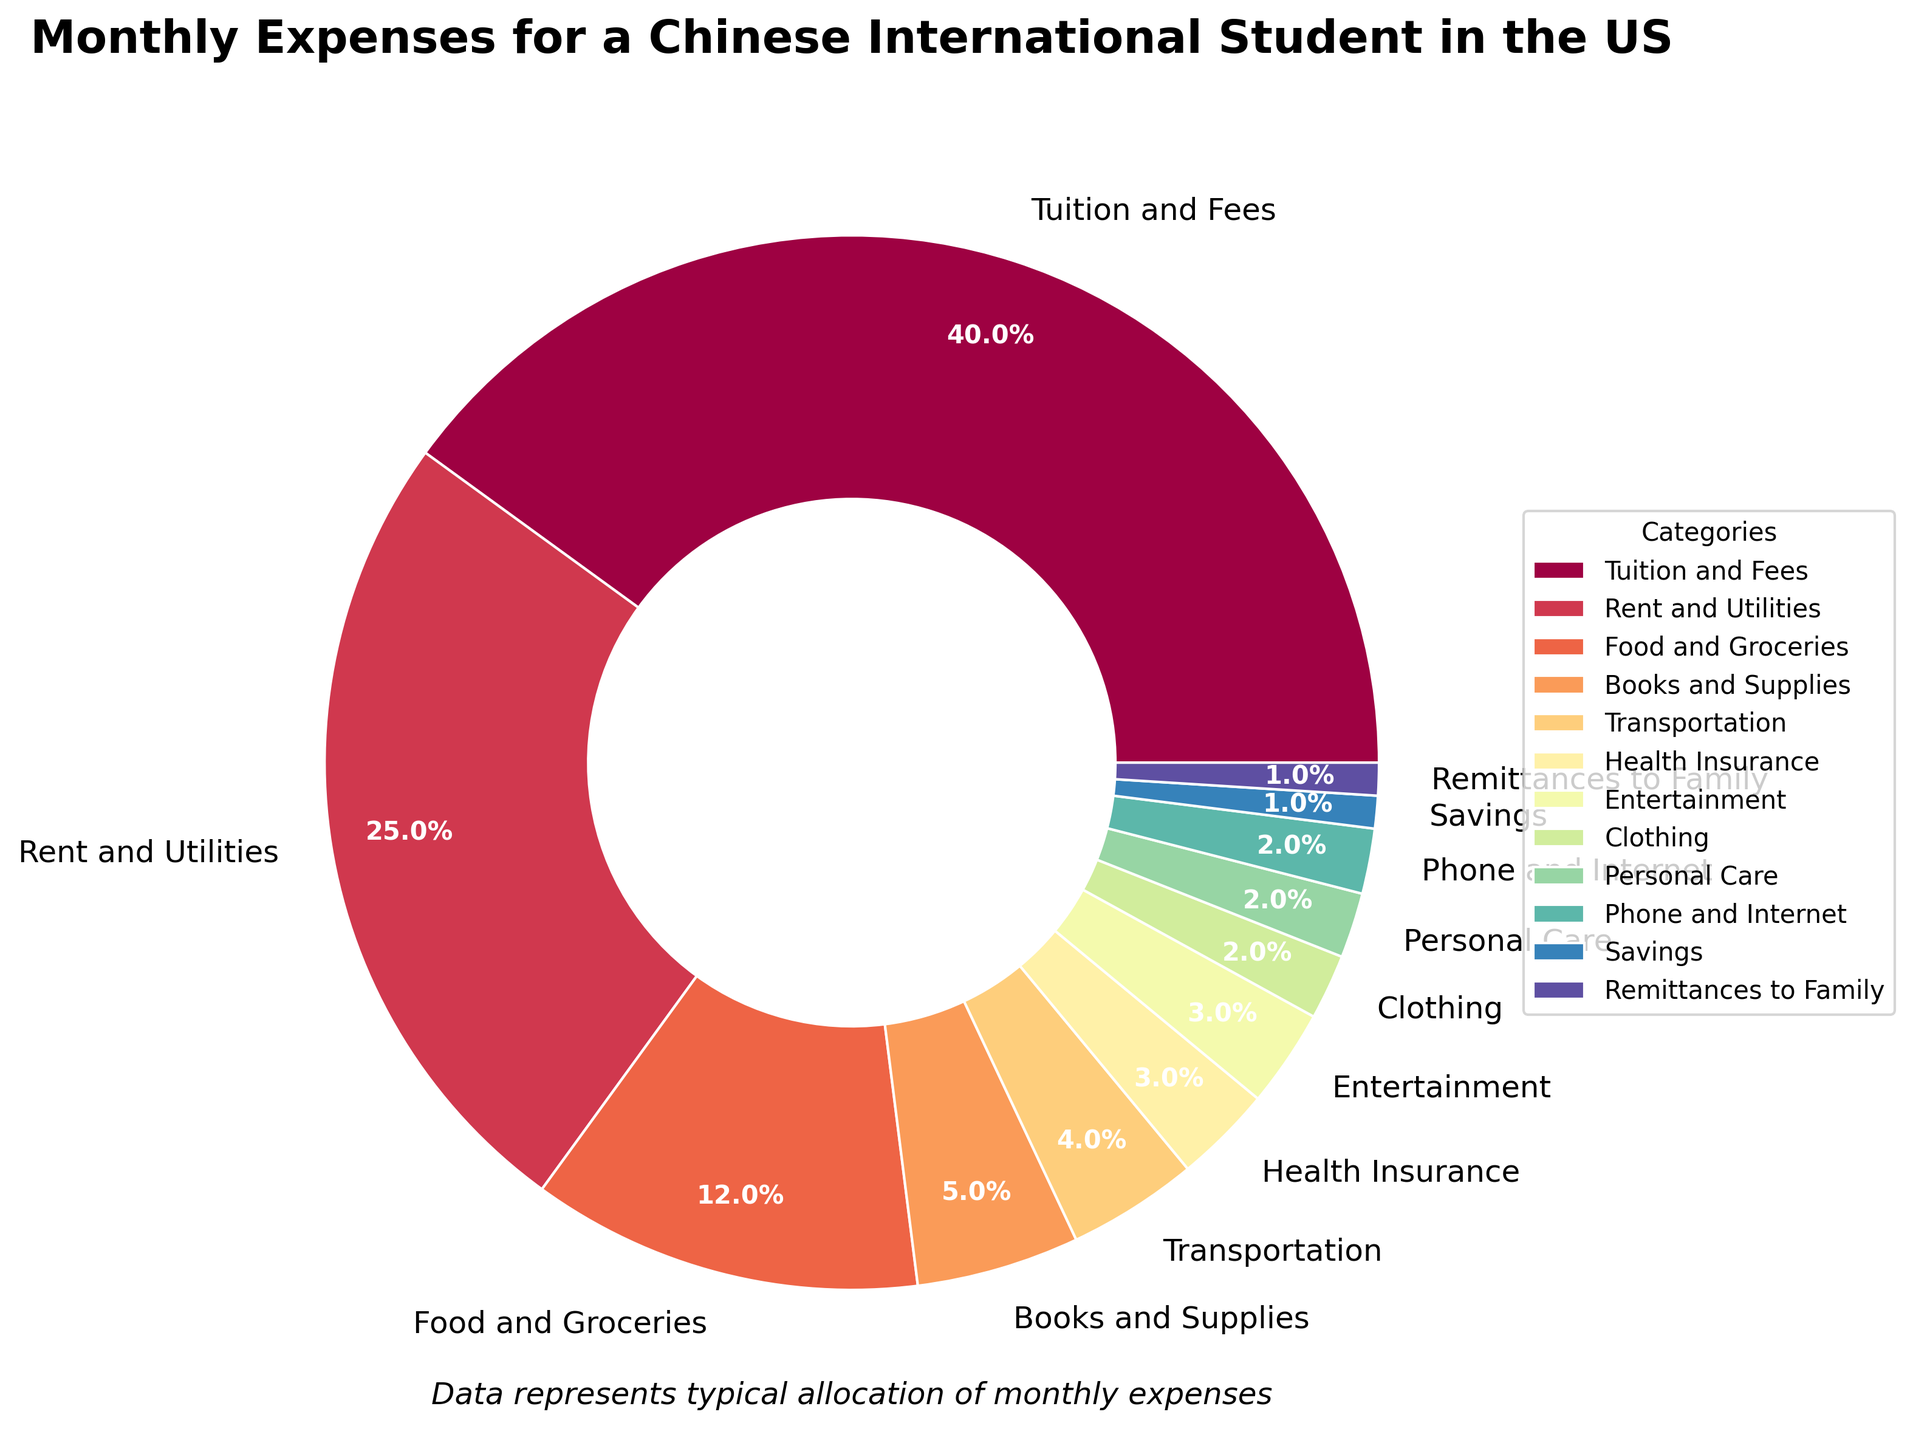Which category has the highest percentage of monthly expenses? The 'Tuition and Fees' slice occupies the largest area on the pie chart with a label showing 40%, indicating it's the highest.
Answer: Tuition and Fees How much more is spent on Rent and Utilities than on Food and Groceries? Rent and Utilities account for 25%, and Food and Groceries account for 12%. The difference is 25% - 12%.
Answer: 13% Which two categories have an equal percentage of expenses? Entertainment and Health Insurance each occupy slices in the pie chart marked as 3%.
Answer: Entertainment, Health Insurance What is the combined percentage of monthly expenses spent on Books and Supplies and Transportation? Books and Supplies account for 5%, and Transportation accounts for 4%. Adding these together gives 5% + 4%.
Answer: 9% Compare the percentages spent on Entertainment and on Personal Care. Which is higher? Entertainment accounts for 3%, while Personal Care accounts for 2%. Therefore, Entertainment is higher.
Answer: Entertainment How much more is allocated to Food and Groceries compared to Clothing? Food and Groceries is 12%, and Clothing is 2%. The difference is 12% - 2%.
Answer: 10% What is the total percentage of expenses allocated to categories that each account for 2%? Categories at 2% are Clothing, Personal Care, and Phone and Internet. Summing these gives 2% + 2% + 2%.
Answer: 6% Which expense category is represented by the smallest section of the pie chart? The smallest sections are the ones labeled with the lowest percentages. Both Savings and Remittances to Family are labeled 1%.
Answer: Savings, Remittances to Family What color represents the Food and Groceries section in the chart? The pie chart's color scheme uses different colors for each category. Locate the 'Food and Groceries' label and identify its color.
Answer: (Color varies depending on the plot) If the percentage for Transport was doubled, how much space would it occupy? Transportation is currently 4%. If doubled, it would be 4% x 2, which equals 8%.
Answer: 8% 